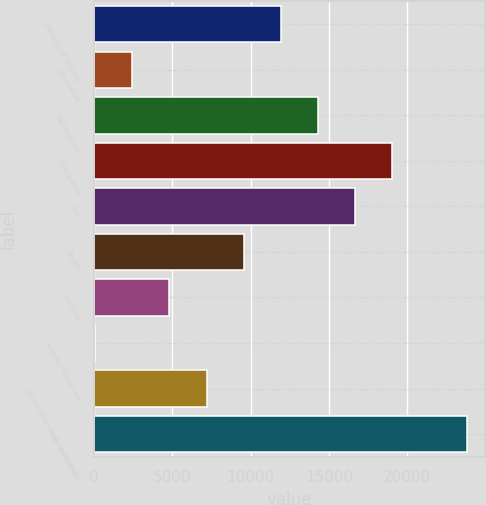Convert chart. <chart><loc_0><loc_0><loc_500><loc_500><bar_chart><fcel>(Millions of Dollars)<fcel>Generation<fcel>Transmission<fcel>Distribution<fcel>Gas<fcel>Steam<fcel>General<fcel>Held for future use<fcel>Construction work in progress<fcel>Net Utility Plant<nl><fcel>11933<fcel>2444.2<fcel>14305.2<fcel>19049.6<fcel>16677.4<fcel>9560.8<fcel>4816.4<fcel>72<fcel>7188.6<fcel>23794<nl></chart> 